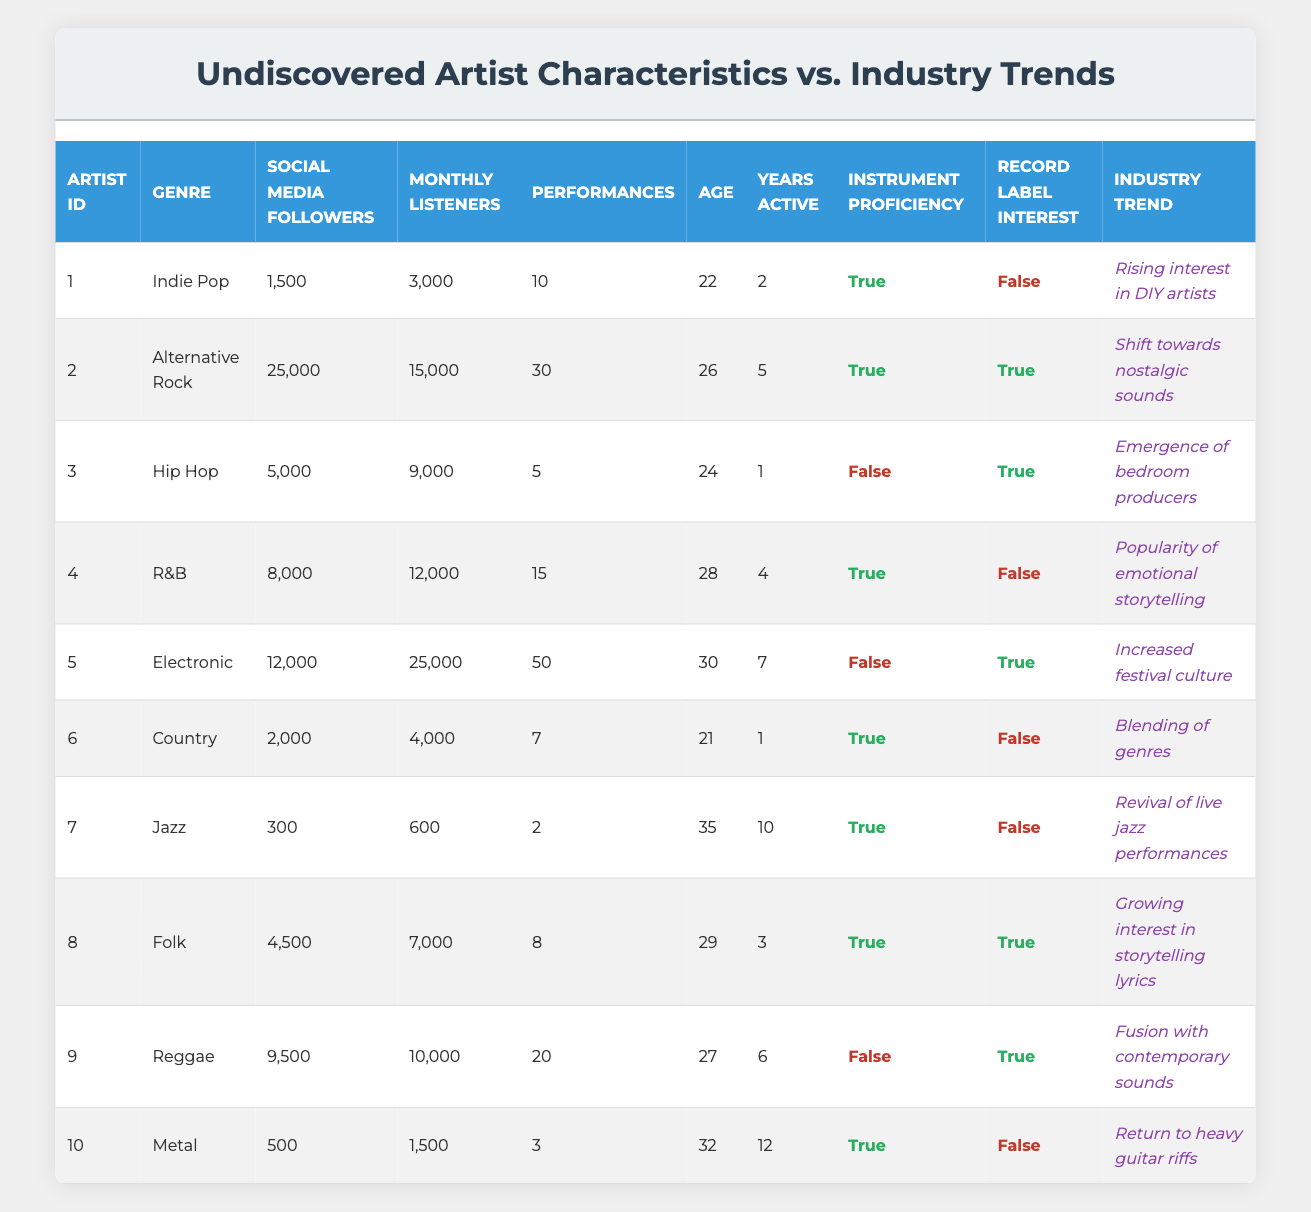What is the genre of the artist with the highest number of social media followers? The artist with the highest number of social media followers is identified in the table. By reviewing the "Social Media Followers" column, we find that the artist ID 2 has 25,000 followers and is categorized under "Alternative Rock," which is the highest.
Answer: Alternative Rock How many performances has the youngest artist given? To find this, we need to check the age of each artist listed in the table. The youngest artist is artist ID 6, who is 21 years old, and has given 7 performances.
Answer: 7 Which artist has a record label interest and instrument proficiency but the lowest monthly listeners? Reviewing the table, artist ID 3 has record label interest marked as true and instrument proficiency as false. The artist ID 1 has both true for instrument proficiency and false for record label interest but does not meet the criteria since artist ID 3 fits the condition better and has 9,000 monthly listeners.
Answer: Artist ID 3 What is the average number of performances for artists with instrumental proficiency? First, we identify the artists with instrumental proficiency (IDs 1, 2, 4, 6, 7, 8, and 10) and then list their performances: 10, 30, 15, 7, 2, 8, and 3 respectively. Adding these up gives 10 + 30 + 15 + 7 + 2 + 8 + 3 = 75. The count of these artists is 7, so the average is 75 / 7 = 10.71.
Answer: 10.71 Is there a trend in the industry where artists without record label interest are gaining popularity? From the table, comparing the industry trends for artists without record label interest (IDs 1, 4, 6, 7, and 10), the trends include "Rising interest in DIY artists," "Popularity of emotional storytelling," "Blending of genres," "Revival of live jazz performances," and "Return to heavy guitar riffs," indicating a potential shift towards appreciating indie or alternative routes.
Answer: Yes 